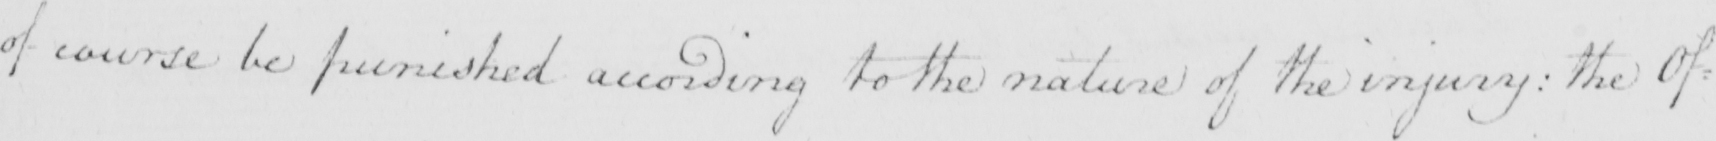What text is written in this handwritten line? of course be punished according to the nature of the injury :  the Of : 